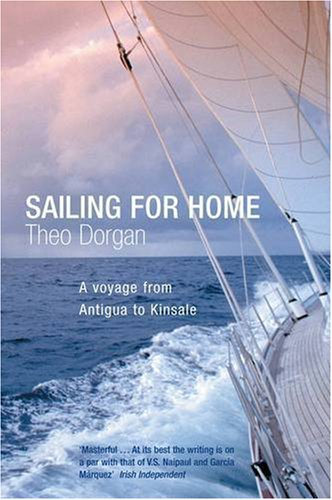What can you tell me about the emotional tone or atmosphere evoked by this book cover? The mood on the book cover evokes a sense of adventure and solemnity, highlighting the vastness of the ocean and the solitude it can entail. It suggests a deep personal journey amidst the elemental forces of nature. 